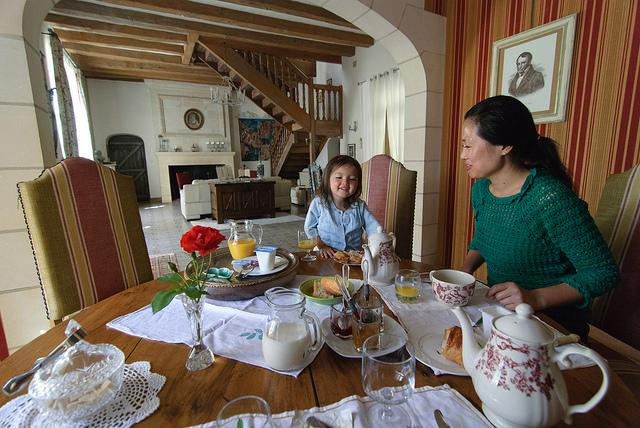Where does porcelain originally come from? china 